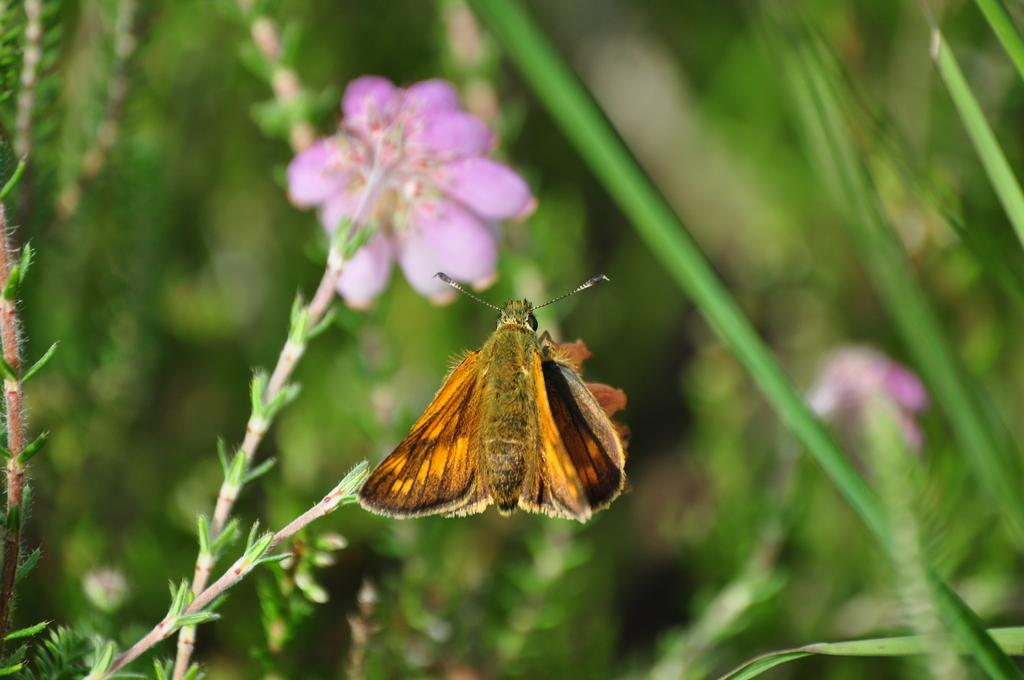What is on the plant in the image? There is an insect on a plant in the image. What type of plants can be seen in the image? There are plants with flowers in the image. What can be seen in the background of the image? There are plants in the background of the image. How does the honey drip from the potato in the image? There is no potato or honey present in the image; it features an insect on a plant and other plants with flowers. 